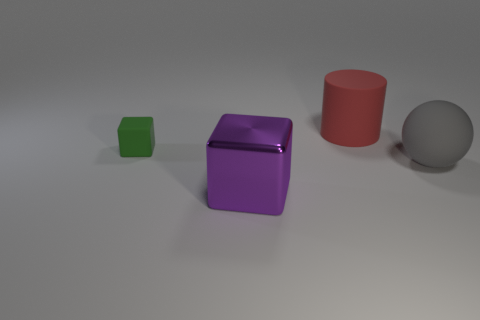Add 4 purple metal spheres. How many objects exist? 8 Subtract all green cubes. How many cubes are left? 1 Subtract 1 cylinders. How many cylinders are left? 0 Subtract all spheres. How many objects are left? 3 Subtract all yellow cylinders. Subtract all brown balls. How many cylinders are left? 1 Subtract all metal blocks. Subtract all red rubber cylinders. How many objects are left? 2 Add 1 big matte spheres. How many big matte spheres are left? 2 Add 2 big matte balls. How many big matte balls exist? 3 Subtract 1 purple cubes. How many objects are left? 3 